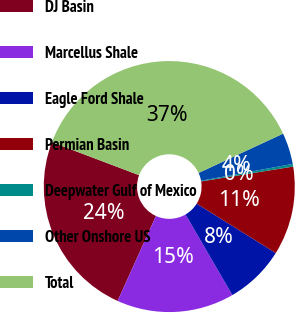Convert chart. <chart><loc_0><loc_0><loc_500><loc_500><pie_chart><fcel>DJ Basin<fcel>Marcellus Shale<fcel>Eagle Ford Shale<fcel>Permian Basin<fcel>Deepwater Gulf of Mexico<fcel>Other Onshore US<fcel>Total<nl><fcel>24.0%<fcel>15.13%<fcel>7.74%<fcel>11.43%<fcel>0.34%<fcel>4.04%<fcel>37.32%<nl></chart> 